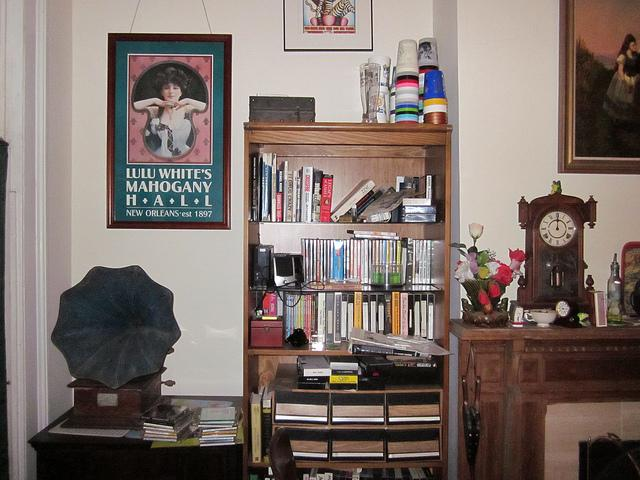Where is this bookshelf located? house 